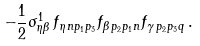Convert formula to latex. <formula><loc_0><loc_0><loc_500><loc_500>- \frac { 1 } { 2 } \sigma ^ { 1 } _ { \eta \beta } \, f _ { \eta \, n p _ { 1 } p _ { 3 } } f _ { \beta \, p _ { 2 } p _ { 1 } n } f _ { \gamma \, p _ { 2 } p _ { 3 } q } \, .</formula> 